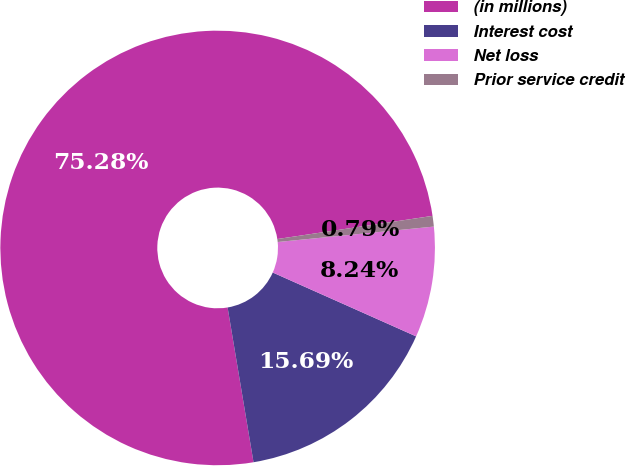<chart> <loc_0><loc_0><loc_500><loc_500><pie_chart><fcel>(in millions)<fcel>Interest cost<fcel>Net loss<fcel>Prior service credit<nl><fcel>75.29%<fcel>15.69%<fcel>8.24%<fcel>0.79%<nl></chart> 